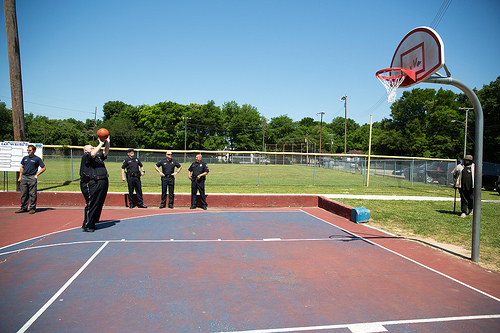<image>
Can you confirm if the fence is behind the man? Yes. From this viewpoint, the fence is positioned behind the man, with the man partially or fully occluding the fence. Is the sky behind the tree? Yes. From this viewpoint, the sky is positioned behind the tree, with the tree partially or fully occluding the sky. 